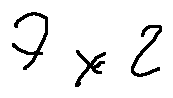<formula> <loc_0><loc_0><loc_500><loc_500>7 \times 2</formula> 